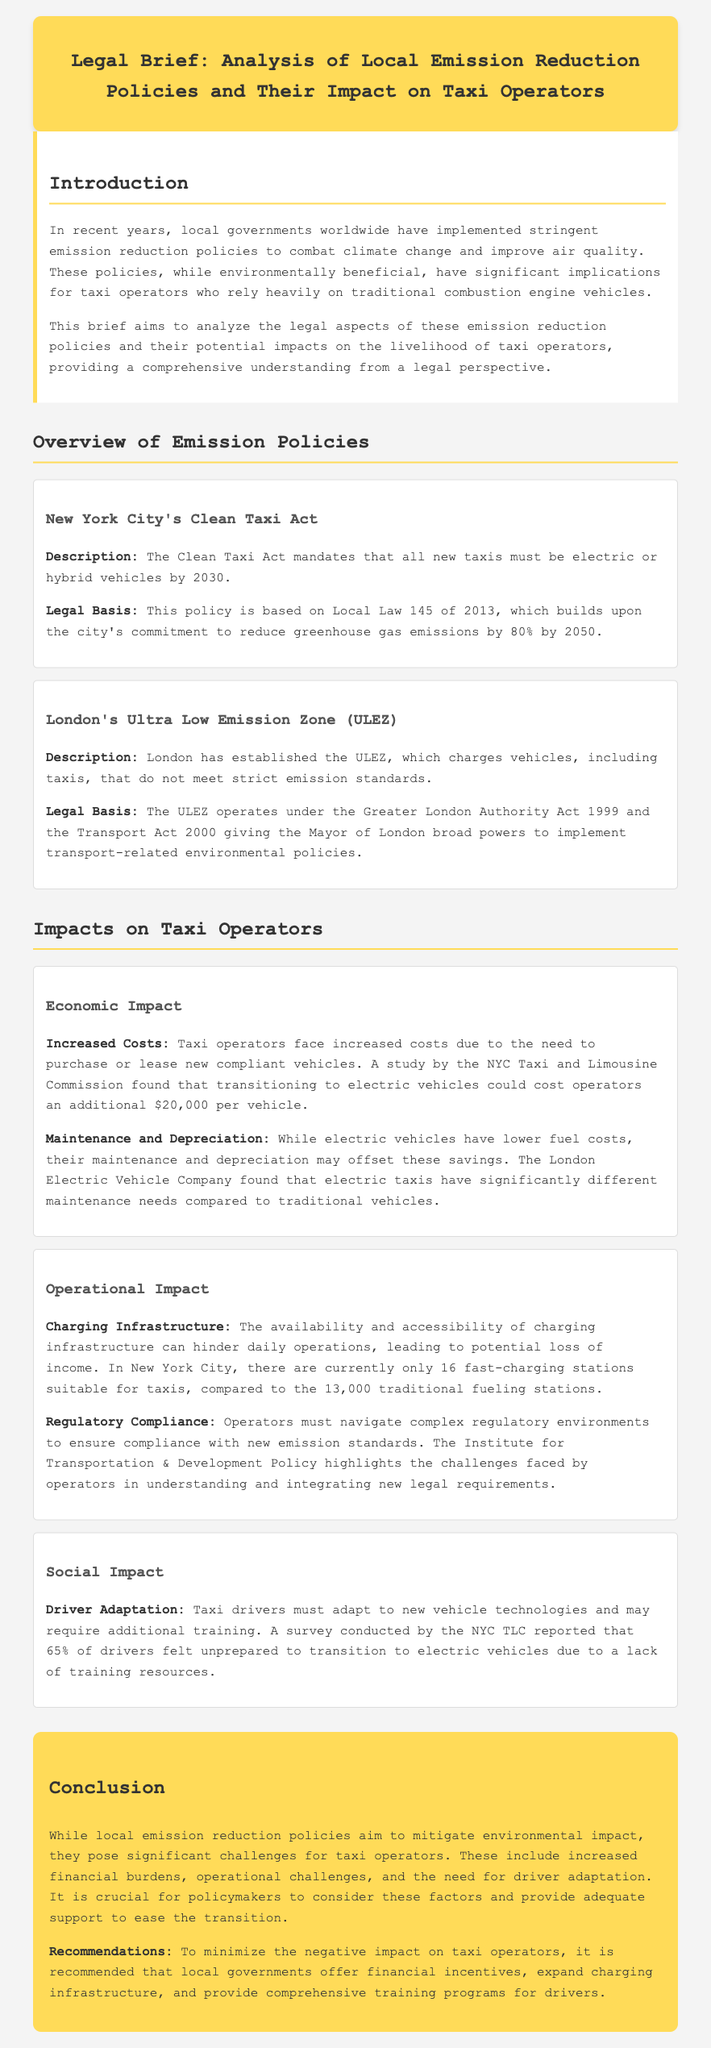What is the title of the legal brief? The title is prominently displayed at the top of the document and states the focus on emission reduction policies.
Answer: Analysis of Local Emission Reduction Policies and Their Impact on Taxi Operators What year must all new taxis be electric or hybrid according to the Clean Taxi Act? The Clean Taxi Act specifies a deadline for compliance regarding vehicle types.
Answer: 2030 What additional cost do NYC taxi operators face for transitioning to electric vehicles? The document highlights the financial implications of transitioning to new vehicle types for operators.
Answer: $20,000 How many fast-charging stations are currently available for taxis in New York City? This figure illustrates the existing infrastructure available for taxi operators transitioning to electric vehicles.
Answer: 16 What percentage of taxi drivers felt unprepared to transition to electric vehicles? The survey referenced provides a statistic on drivers' readiness to adapt to new vehicle technologies.
Answer: 65% What is one recommendation for local governments to support taxi operators? This recommendation addresses how local governments can assist during the transition to new emission standards.
Answer: Financial incentives What is the primary legal basis for London's ULEZ? This policy has a specific legal framework that establishes its authority and operational procedures.
Answer: The Greater London Authority Act 1999 What is one social impact mentioned in the document regarding taxi drivers? The document discusses the training requirements for drivers due to technological changes.
Answer: Driver adaptation 